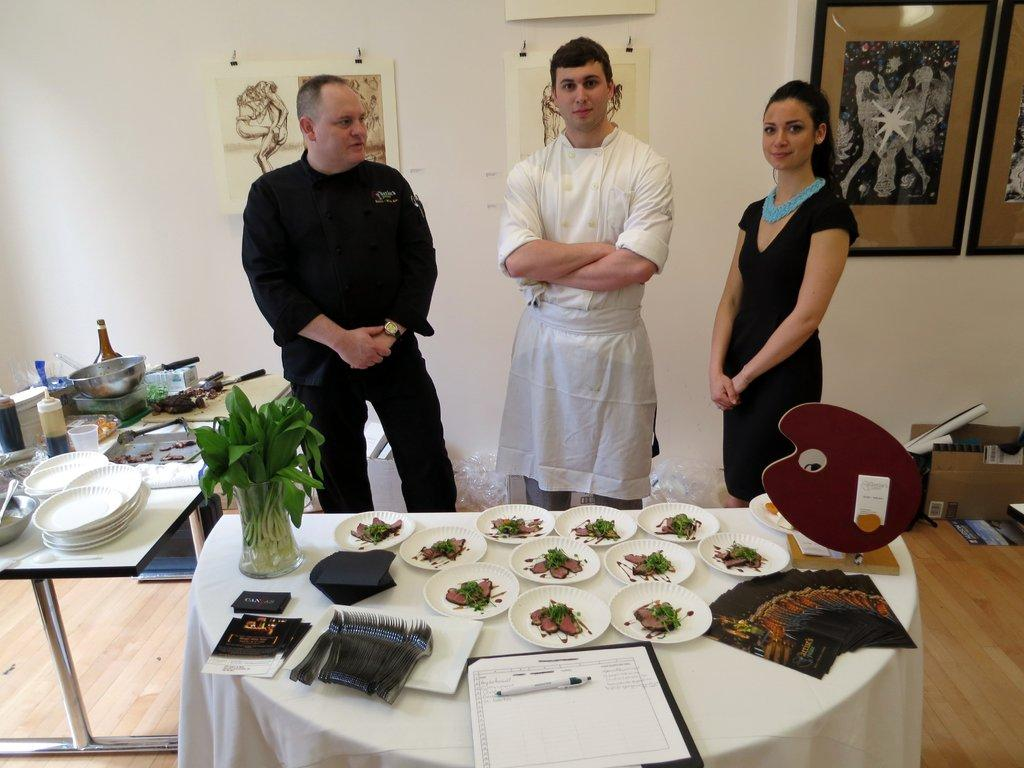How many people are in the image? There are three persons standing in the image. What is the surface they are standing on? The persons are standing on the floor. What can be seen in the image besides the people? There is a table in the image, with food items and other objects on it. What is visible on the wall in the image? There is a wall in the image, with photo frames present on it. What type of chalk is being used by the person in the image? There is no chalk present in the image. 